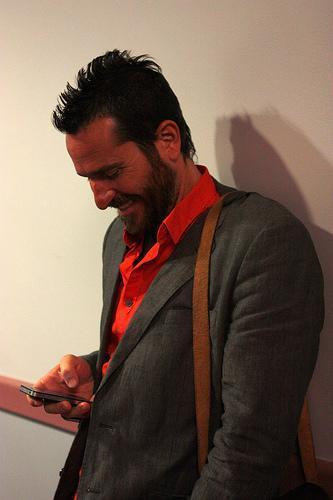How many people are there?
Give a very brief answer. 1. 